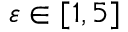Convert formula to latex. <formula><loc_0><loc_0><loc_500><loc_500>\varepsilon \in [ 1 , 5 ]</formula> 